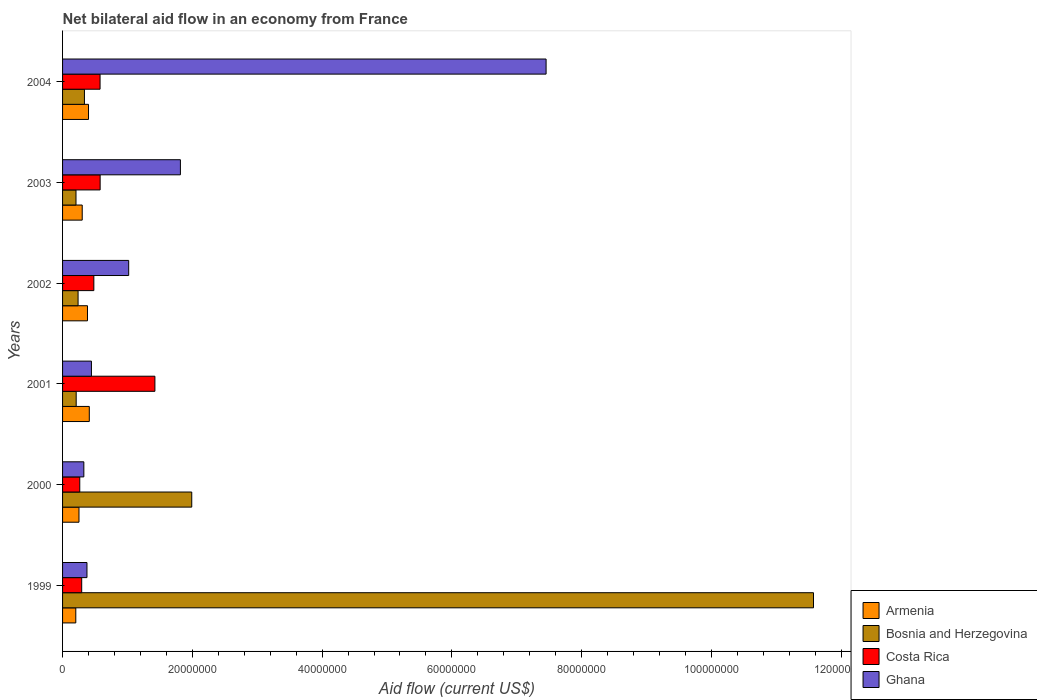How many different coloured bars are there?
Make the answer very short. 4. How many groups of bars are there?
Ensure brevity in your answer.  6. Are the number of bars per tick equal to the number of legend labels?
Make the answer very short. Yes. Are the number of bars on each tick of the Y-axis equal?
Give a very brief answer. Yes. In how many cases, is the number of bars for a given year not equal to the number of legend labels?
Keep it short and to the point. 0. What is the net bilateral aid flow in Armenia in 2003?
Your answer should be very brief. 3.03e+06. Across all years, what is the maximum net bilateral aid flow in Armenia?
Your answer should be very brief. 4.12e+06. Across all years, what is the minimum net bilateral aid flow in Bosnia and Herzegovina?
Your answer should be very brief. 2.07e+06. What is the total net bilateral aid flow in Costa Rica in the graph?
Provide a succinct answer. 3.62e+07. What is the difference between the net bilateral aid flow in Costa Rica in 2001 and that in 2003?
Offer a terse response. 8.44e+06. What is the difference between the net bilateral aid flow in Costa Rica in 2001 and the net bilateral aid flow in Armenia in 2003?
Offer a terse response. 1.12e+07. What is the average net bilateral aid flow in Armenia per year?
Your answer should be compact. 3.26e+06. In the year 2000, what is the difference between the net bilateral aid flow in Ghana and net bilateral aid flow in Costa Rica?
Make the answer very short. 6.30e+05. What is the ratio of the net bilateral aid flow in Bosnia and Herzegovina in 2001 to that in 2003?
Offer a terse response. 1.01. Is the net bilateral aid flow in Bosnia and Herzegovina in 2002 less than that in 2004?
Keep it short and to the point. Yes. What is the difference between the highest and the second highest net bilateral aid flow in Armenia?
Keep it short and to the point. 1.20e+05. What is the difference between the highest and the lowest net bilateral aid flow in Ghana?
Your response must be concise. 7.12e+07. In how many years, is the net bilateral aid flow in Costa Rica greater than the average net bilateral aid flow in Costa Rica taken over all years?
Offer a very short reply. 1. Is the sum of the net bilateral aid flow in Ghana in 2000 and 2004 greater than the maximum net bilateral aid flow in Armenia across all years?
Offer a terse response. Yes. Is it the case that in every year, the sum of the net bilateral aid flow in Costa Rica and net bilateral aid flow in Ghana is greater than the sum of net bilateral aid flow in Armenia and net bilateral aid flow in Bosnia and Herzegovina?
Give a very brief answer. No. What does the 4th bar from the top in 2002 represents?
Offer a terse response. Armenia. What does the 1st bar from the bottom in 2004 represents?
Make the answer very short. Armenia. Is it the case that in every year, the sum of the net bilateral aid flow in Costa Rica and net bilateral aid flow in Armenia is greater than the net bilateral aid flow in Bosnia and Herzegovina?
Offer a terse response. No. How many years are there in the graph?
Provide a short and direct response. 6. What is the difference between two consecutive major ticks on the X-axis?
Offer a very short reply. 2.00e+07. Are the values on the major ticks of X-axis written in scientific E-notation?
Offer a very short reply. No. Does the graph contain grids?
Offer a very short reply. No. Where does the legend appear in the graph?
Provide a succinct answer. Bottom right. How many legend labels are there?
Give a very brief answer. 4. What is the title of the graph?
Your answer should be very brief. Net bilateral aid flow in an economy from France. Does "Uganda" appear as one of the legend labels in the graph?
Provide a succinct answer. No. What is the label or title of the Y-axis?
Provide a short and direct response. Years. What is the Aid flow (current US$) of Armenia in 1999?
Make the answer very short. 2.04e+06. What is the Aid flow (current US$) in Bosnia and Herzegovina in 1999?
Give a very brief answer. 1.16e+08. What is the Aid flow (current US$) of Costa Rica in 1999?
Provide a succinct answer. 2.95e+06. What is the Aid flow (current US$) in Ghana in 1999?
Offer a terse response. 3.76e+06. What is the Aid flow (current US$) of Armenia in 2000?
Keep it short and to the point. 2.53e+06. What is the Aid flow (current US$) in Bosnia and Herzegovina in 2000?
Offer a very short reply. 1.99e+07. What is the Aid flow (current US$) in Costa Rica in 2000?
Provide a short and direct response. 2.65e+06. What is the Aid flow (current US$) of Ghana in 2000?
Your response must be concise. 3.28e+06. What is the Aid flow (current US$) of Armenia in 2001?
Make the answer very short. 4.12e+06. What is the Aid flow (current US$) in Bosnia and Herzegovina in 2001?
Your response must be concise. 2.10e+06. What is the Aid flow (current US$) of Costa Rica in 2001?
Ensure brevity in your answer.  1.42e+07. What is the Aid flow (current US$) in Ghana in 2001?
Ensure brevity in your answer.  4.45e+06. What is the Aid flow (current US$) in Armenia in 2002?
Offer a terse response. 3.84e+06. What is the Aid flow (current US$) of Bosnia and Herzegovina in 2002?
Give a very brief answer. 2.39e+06. What is the Aid flow (current US$) of Costa Rica in 2002?
Your answer should be compact. 4.82e+06. What is the Aid flow (current US$) in Ghana in 2002?
Your response must be concise. 1.02e+07. What is the Aid flow (current US$) in Armenia in 2003?
Your answer should be very brief. 3.03e+06. What is the Aid flow (current US$) of Bosnia and Herzegovina in 2003?
Your answer should be compact. 2.07e+06. What is the Aid flow (current US$) of Costa Rica in 2003?
Keep it short and to the point. 5.79e+06. What is the Aid flow (current US$) of Ghana in 2003?
Provide a short and direct response. 1.82e+07. What is the Aid flow (current US$) of Armenia in 2004?
Ensure brevity in your answer.  4.00e+06. What is the Aid flow (current US$) of Bosnia and Herzegovina in 2004?
Ensure brevity in your answer.  3.37e+06. What is the Aid flow (current US$) in Costa Rica in 2004?
Your response must be concise. 5.78e+06. What is the Aid flow (current US$) of Ghana in 2004?
Provide a succinct answer. 7.45e+07. Across all years, what is the maximum Aid flow (current US$) in Armenia?
Offer a terse response. 4.12e+06. Across all years, what is the maximum Aid flow (current US$) of Bosnia and Herzegovina?
Your response must be concise. 1.16e+08. Across all years, what is the maximum Aid flow (current US$) in Costa Rica?
Keep it short and to the point. 1.42e+07. Across all years, what is the maximum Aid flow (current US$) in Ghana?
Offer a terse response. 7.45e+07. Across all years, what is the minimum Aid flow (current US$) of Armenia?
Offer a very short reply. 2.04e+06. Across all years, what is the minimum Aid flow (current US$) of Bosnia and Herzegovina?
Provide a succinct answer. 2.07e+06. Across all years, what is the minimum Aid flow (current US$) in Costa Rica?
Ensure brevity in your answer.  2.65e+06. Across all years, what is the minimum Aid flow (current US$) in Ghana?
Offer a very short reply. 3.28e+06. What is the total Aid flow (current US$) of Armenia in the graph?
Your answer should be compact. 1.96e+07. What is the total Aid flow (current US$) in Bosnia and Herzegovina in the graph?
Offer a terse response. 1.46e+08. What is the total Aid flow (current US$) in Costa Rica in the graph?
Your response must be concise. 3.62e+07. What is the total Aid flow (current US$) of Ghana in the graph?
Your answer should be compact. 1.14e+08. What is the difference between the Aid flow (current US$) of Armenia in 1999 and that in 2000?
Provide a short and direct response. -4.90e+05. What is the difference between the Aid flow (current US$) in Bosnia and Herzegovina in 1999 and that in 2000?
Keep it short and to the point. 9.58e+07. What is the difference between the Aid flow (current US$) in Costa Rica in 1999 and that in 2000?
Your response must be concise. 3.00e+05. What is the difference between the Aid flow (current US$) of Ghana in 1999 and that in 2000?
Your answer should be compact. 4.80e+05. What is the difference between the Aid flow (current US$) in Armenia in 1999 and that in 2001?
Provide a short and direct response. -2.08e+06. What is the difference between the Aid flow (current US$) in Bosnia and Herzegovina in 1999 and that in 2001?
Make the answer very short. 1.14e+08. What is the difference between the Aid flow (current US$) in Costa Rica in 1999 and that in 2001?
Your response must be concise. -1.13e+07. What is the difference between the Aid flow (current US$) in Ghana in 1999 and that in 2001?
Provide a short and direct response. -6.90e+05. What is the difference between the Aid flow (current US$) of Armenia in 1999 and that in 2002?
Provide a succinct answer. -1.80e+06. What is the difference between the Aid flow (current US$) of Bosnia and Herzegovina in 1999 and that in 2002?
Your answer should be very brief. 1.13e+08. What is the difference between the Aid flow (current US$) of Costa Rica in 1999 and that in 2002?
Offer a terse response. -1.87e+06. What is the difference between the Aid flow (current US$) in Ghana in 1999 and that in 2002?
Ensure brevity in your answer.  -6.43e+06. What is the difference between the Aid flow (current US$) in Armenia in 1999 and that in 2003?
Ensure brevity in your answer.  -9.90e+05. What is the difference between the Aid flow (current US$) of Bosnia and Herzegovina in 1999 and that in 2003?
Make the answer very short. 1.14e+08. What is the difference between the Aid flow (current US$) of Costa Rica in 1999 and that in 2003?
Offer a very short reply. -2.84e+06. What is the difference between the Aid flow (current US$) of Ghana in 1999 and that in 2003?
Ensure brevity in your answer.  -1.44e+07. What is the difference between the Aid flow (current US$) of Armenia in 1999 and that in 2004?
Make the answer very short. -1.96e+06. What is the difference between the Aid flow (current US$) of Bosnia and Herzegovina in 1999 and that in 2004?
Your answer should be very brief. 1.12e+08. What is the difference between the Aid flow (current US$) of Costa Rica in 1999 and that in 2004?
Give a very brief answer. -2.83e+06. What is the difference between the Aid flow (current US$) in Ghana in 1999 and that in 2004?
Keep it short and to the point. -7.08e+07. What is the difference between the Aid flow (current US$) of Armenia in 2000 and that in 2001?
Offer a very short reply. -1.59e+06. What is the difference between the Aid flow (current US$) in Bosnia and Herzegovina in 2000 and that in 2001?
Make the answer very short. 1.78e+07. What is the difference between the Aid flow (current US$) in Costa Rica in 2000 and that in 2001?
Your answer should be very brief. -1.16e+07. What is the difference between the Aid flow (current US$) in Ghana in 2000 and that in 2001?
Your answer should be compact. -1.17e+06. What is the difference between the Aid flow (current US$) of Armenia in 2000 and that in 2002?
Keep it short and to the point. -1.31e+06. What is the difference between the Aid flow (current US$) in Bosnia and Herzegovina in 2000 and that in 2002?
Give a very brief answer. 1.75e+07. What is the difference between the Aid flow (current US$) of Costa Rica in 2000 and that in 2002?
Keep it short and to the point. -2.17e+06. What is the difference between the Aid flow (current US$) of Ghana in 2000 and that in 2002?
Provide a succinct answer. -6.91e+06. What is the difference between the Aid flow (current US$) in Armenia in 2000 and that in 2003?
Offer a terse response. -5.00e+05. What is the difference between the Aid flow (current US$) in Bosnia and Herzegovina in 2000 and that in 2003?
Give a very brief answer. 1.78e+07. What is the difference between the Aid flow (current US$) of Costa Rica in 2000 and that in 2003?
Keep it short and to the point. -3.14e+06. What is the difference between the Aid flow (current US$) of Ghana in 2000 and that in 2003?
Keep it short and to the point. -1.49e+07. What is the difference between the Aid flow (current US$) in Armenia in 2000 and that in 2004?
Your response must be concise. -1.47e+06. What is the difference between the Aid flow (current US$) in Bosnia and Herzegovina in 2000 and that in 2004?
Provide a short and direct response. 1.65e+07. What is the difference between the Aid flow (current US$) in Costa Rica in 2000 and that in 2004?
Give a very brief answer. -3.13e+06. What is the difference between the Aid flow (current US$) in Ghana in 2000 and that in 2004?
Make the answer very short. -7.12e+07. What is the difference between the Aid flow (current US$) in Costa Rica in 2001 and that in 2002?
Provide a succinct answer. 9.41e+06. What is the difference between the Aid flow (current US$) of Ghana in 2001 and that in 2002?
Offer a very short reply. -5.74e+06. What is the difference between the Aid flow (current US$) in Armenia in 2001 and that in 2003?
Your answer should be compact. 1.09e+06. What is the difference between the Aid flow (current US$) of Costa Rica in 2001 and that in 2003?
Provide a short and direct response. 8.44e+06. What is the difference between the Aid flow (current US$) in Ghana in 2001 and that in 2003?
Keep it short and to the point. -1.37e+07. What is the difference between the Aid flow (current US$) in Armenia in 2001 and that in 2004?
Your answer should be compact. 1.20e+05. What is the difference between the Aid flow (current US$) of Bosnia and Herzegovina in 2001 and that in 2004?
Your answer should be very brief. -1.27e+06. What is the difference between the Aid flow (current US$) in Costa Rica in 2001 and that in 2004?
Offer a terse response. 8.45e+06. What is the difference between the Aid flow (current US$) of Ghana in 2001 and that in 2004?
Provide a short and direct response. -7.01e+07. What is the difference between the Aid flow (current US$) in Armenia in 2002 and that in 2003?
Give a very brief answer. 8.10e+05. What is the difference between the Aid flow (current US$) in Bosnia and Herzegovina in 2002 and that in 2003?
Provide a succinct answer. 3.20e+05. What is the difference between the Aid flow (current US$) of Costa Rica in 2002 and that in 2003?
Give a very brief answer. -9.70e+05. What is the difference between the Aid flow (current US$) of Ghana in 2002 and that in 2003?
Your answer should be compact. -7.97e+06. What is the difference between the Aid flow (current US$) of Armenia in 2002 and that in 2004?
Keep it short and to the point. -1.60e+05. What is the difference between the Aid flow (current US$) of Bosnia and Herzegovina in 2002 and that in 2004?
Ensure brevity in your answer.  -9.80e+05. What is the difference between the Aid flow (current US$) in Costa Rica in 2002 and that in 2004?
Make the answer very short. -9.60e+05. What is the difference between the Aid flow (current US$) of Ghana in 2002 and that in 2004?
Make the answer very short. -6.43e+07. What is the difference between the Aid flow (current US$) of Armenia in 2003 and that in 2004?
Give a very brief answer. -9.70e+05. What is the difference between the Aid flow (current US$) in Bosnia and Herzegovina in 2003 and that in 2004?
Offer a very short reply. -1.30e+06. What is the difference between the Aid flow (current US$) in Costa Rica in 2003 and that in 2004?
Provide a short and direct response. 10000. What is the difference between the Aid flow (current US$) of Ghana in 2003 and that in 2004?
Offer a terse response. -5.64e+07. What is the difference between the Aid flow (current US$) in Armenia in 1999 and the Aid flow (current US$) in Bosnia and Herzegovina in 2000?
Keep it short and to the point. -1.79e+07. What is the difference between the Aid flow (current US$) of Armenia in 1999 and the Aid flow (current US$) of Costa Rica in 2000?
Give a very brief answer. -6.10e+05. What is the difference between the Aid flow (current US$) in Armenia in 1999 and the Aid flow (current US$) in Ghana in 2000?
Offer a very short reply. -1.24e+06. What is the difference between the Aid flow (current US$) of Bosnia and Herzegovina in 1999 and the Aid flow (current US$) of Costa Rica in 2000?
Offer a terse response. 1.13e+08. What is the difference between the Aid flow (current US$) of Bosnia and Herzegovina in 1999 and the Aid flow (current US$) of Ghana in 2000?
Provide a short and direct response. 1.12e+08. What is the difference between the Aid flow (current US$) in Costa Rica in 1999 and the Aid flow (current US$) in Ghana in 2000?
Provide a succinct answer. -3.30e+05. What is the difference between the Aid flow (current US$) in Armenia in 1999 and the Aid flow (current US$) in Bosnia and Herzegovina in 2001?
Your answer should be compact. -6.00e+04. What is the difference between the Aid flow (current US$) of Armenia in 1999 and the Aid flow (current US$) of Costa Rica in 2001?
Your response must be concise. -1.22e+07. What is the difference between the Aid flow (current US$) in Armenia in 1999 and the Aid flow (current US$) in Ghana in 2001?
Your response must be concise. -2.41e+06. What is the difference between the Aid flow (current US$) of Bosnia and Herzegovina in 1999 and the Aid flow (current US$) of Costa Rica in 2001?
Offer a very short reply. 1.02e+08. What is the difference between the Aid flow (current US$) in Bosnia and Herzegovina in 1999 and the Aid flow (current US$) in Ghana in 2001?
Provide a succinct answer. 1.11e+08. What is the difference between the Aid flow (current US$) of Costa Rica in 1999 and the Aid flow (current US$) of Ghana in 2001?
Make the answer very short. -1.50e+06. What is the difference between the Aid flow (current US$) in Armenia in 1999 and the Aid flow (current US$) in Bosnia and Herzegovina in 2002?
Give a very brief answer. -3.50e+05. What is the difference between the Aid flow (current US$) of Armenia in 1999 and the Aid flow (current US$) of Costa Rica in 2002?
Your answer should be very brief. -2.78e+06. What is the difference between the Aid flow (current US$) of Armenia in 1999 and the Aid flow (current US$) of Ghana in 2002?
Give a very brief answer. -8.15e+06. What is the difference between the Aid flow (current US$) in Bosnia and Herzegovina in 1999 and the Aid flow (current US$) in Costa Rica in 2002?
Your answer should be compact. 1.11e+08. What is the difference between the Aid flow (current US$) in Bosnia and Herzegovina in 1999 and the Aid flow (current US$) in Ghana in 2002?
Ensure brevity in your answer.  1.06e+08. What is the difference between the Aid flow (current US$) in Costa Rica in 1999 and the Aid flow (current US$) in Ghana in 2002?
Ensure brevity in your answer.  -7.24e+06. What is the difference between the Aid flow (current US$) of Armenia in 1999 and the Aid flow (current US$) of Bosnia and Herzegovina in 2003?
Provide a short and direct response. -3.00e+04. What is the difference between the Aid flow (current US$) of Armenia in 1999 and the Aid flow (current US$) of Costa Rica in 2003?
Keep it short and to the point. -3.75e+06. What is the difference between the Aid flow (current US$) in Armenia in 1999 and the Aid flow (current US$) in Ghana in 2003?
Your answer should be compact. -1.61e+07. What is the difference between the Aid flow (current US$) in Bosnia and Herzegovina in 1999 and the Aid flow (current US$) in Costa Rica in 2003?
Your answer should be very brief. 1.10e+08. What is the difference between the Aid flow (current US$) of Bosnia and Herzegovina in 1999 and the Aid flow (current US$) of Ghana in 2003?
Offer a very short reply. 9.76e+07. What is the difference between the Aid flow (current US$) of Costa Rica in 1999 and the Aid flow (current US$) of Ghana in 2003?
Your answer should be compact. -1.52e+07. What is the difference between the Aid flow (current US$) of Armenia in 1999 and the Aid flow (current US$) of Bosnia and Herzegovina in 2004?
Provide a succinct answer. -1.33e+06. What is the difference between the Aid flow (current US$) in Armenia in 1999 and the Aid flow (current US$) in Costa Rica in 2004?
Your answer should be very brief. -3.74e+06. What is the difference between the Aid flow (current US$) in Armenia in 1999 and the Aid flow (current US$) in Ghana in 2004?
Ensure brevity in your answer.  -7.25e+07. What is the difference between the Aid flow (current US$) in Bosnia and Herzegovina in 1999 and the Aid flow (current US$) in Costa Rica in 2004?
Make the answer very short. 1.10e+08. What is the difference between the Aid flow (current US$) in Bosnia and Herzegovina in 1999 and the Aid flow (current US$) in Ghana in 2004?
Keep it short and to the point. 4.12e+07. What is the difference between the Aid flow (current US$) of Costa Rica in 1999 and the Aid flow (current US$) of Ghana in 2004?
Make the answer very short. -7.16e+07. What is the difference between the Aid flow (current US$) in Armenia in 2000 and the Aid flow (current US$) in Costa Rica in 2001?
Provide a short and direct response. -1.17e+07. What is the difference between the Aid flow (current US$) of Armenia in 2000 and the Aid flow (current US$) of Ghana in 2001?
Provide a short and direct response. -1.92e+06. What is the difference between the Aid flow (current US$) in Bosnia and Herzegovina in 2000 and the Aid flow (current US$) in Costa Rica in 2001?
Make the answer very short. 5.68e+06. What is the difference between the Aid flow (current US$) in Bosnia and Herzegovina in 2000 and the Aid flow (current US$) in Ghana in 2001?
Ensure brevity in your answer.  1.55e+07. What is the difference between the Aid flow (current US$) in Costa Rica in 2000 and the Aid flow (current US$) in Ghana in 2001?
Make the answer very short. -1.80e+06. What is the difference between the Aid flow (current US$) of Armenia in 2000 and the Aid flow (current US$) of Bosnia and Herzegovina in 2002?
Provide a succinct answer. 1.40e+05. What is the difference between the Aid flow (current US$) in Armenia in 2000 and the Aid flow (current US$) in Costa Rica in 2002?
Give a very brief answer. -2.29e+06. What is the difference between the Aid flow (current US$) in Armenia in 2000 and the Aid flow (current US$) in Ghana in 2002?
Your response must be concise. -7.66e+06. What is the difference between the Aid flow (current US$) of Bosnia and Herzegovina in 2000 and the Aid flow (current US$) of Costa Rica in 2002?
Your response must be concise. 1.51e+07. What is the difference between the Aid flow (current US$) in Bosnia and Herzegovina in 2000 and the Aid flow (current US$) in Ghana in 2002?
Provide a short and direct response. 9.72e+06. What is the difference between the Aid flow (current US$) in Costa Rica in 2000 and the Aid flow (current US$) in Ghana in 2002?
Make the answer very short. -7.54e+06. What is the difference between the Aid flow (current US$) in Armenia in 2000 and the Aid flow (current US$) in Costa Rica in 2003?
Ensure brevity in your answer.  -3.26e+06. What is the difference between the Aid flow (current US$) in Armenia in 2000 and the Aid flow (current US$) in Ghana in 2003?
Your answer should be compact. -1.56e+07. What is the difference between the Aid flow (current US$) of Bosnia and Herzegovina in 2000 and the Aid flow (current US$) of Costa Rica in 2003?
Your answer should be very brief. 1.41e+07. What is the difference between the Aid flow (current US$) in Bosnia and Herzegovina in 2000 and the Aid flow (current US$) in Ghana in 2003?
Make the answer very short. 1.75e+06. What is the difference between the Aid flow (current US$) of Costa Rica in 2000 and the Aid flow (current US$) of Ghana in 2003?
Give a very brief answer. -1.55e+07. What is the difference between the Aid flow (current US$) of Armenia in 2000 and the Aid flow (current US$) of Bosnia and Herzegovina in 2004?
Provide a short and direct response. -8.40e+05. What is the difference between the Aid flow (current US$) of Armenia in 2000 and the Aid flow (current US$) of Costa Rica in 2004?
Give a very brief answer. -3.25e+06. What is the difference between the Aid flow (current US$) of Armenia in 2000 and the Aid flow (current US$) of Ghana in 2004?
Your response must be concise. -7.20e+07. What is the difference between the Aid flow (current US$) of Bosnia and Herzegovina in 2000 and the Aid flow (current US$) of Costa Rica in 2004?
Your response must be concise. 1.41e+07. What is the difference between the Aid flow (current US$) of Bosnia and Herzegovina in 2000 and the Aid flow (current US$) of Ghana in 2004?
Ensure brevity in your answer.  -5.46e+07. What is the difference between the Aid flow (current US$) in Costa Rica in 2000 and the Aid flow (current US$) in Ghana in 2004?
Provide a short and direct response. -7.19e+07. What is the difference between the Aid flow (current US$) of Armenia in 2001 and the Aid flow (current US$) of Bosnia and Herzegovina in 2002?
Your answer should be compact. 1.73e+06. What is the difference between the Aid flow (current US$) in Armenia in 2001 and the Aid flow (current US$) in Costa Rica in 2002?
Give a very brief answer. -7.00e+05. What is the difference between the Aid flow (current US$) in Armenia in 2001 and the Aid flow (current US$) in Ghana in 2002?
Your response must be concise. -6.07e+06. What is the difference between the Aid flow (current US$) in Bosnia and Herzegovina in 2001 and the Aid flow (current US$) in Costa Rica in 2002?
Your answer should be compact. -2.72e+06. What is the difference between the Aid flow (current US$) of Bosnia and Herzegovina in 2001 and the Aid flow (current US$) of Ghana in 2002?
Ensure brevity in your answer.  -8.09e+06. What is the difference between the Aid flow (current US$) in Costa Rica in 2001 and the Aid flow (current US$) in Ghana in 2002?
Offer a terse response. 4.04e+06. What is the difference between the Aid flow (current US$) in Armenia in 2001 and the Aid flow (current US$) in Bosnia and Herzegovina in 2003?
Offer a terse response. 2.05e+06. What is the difference between the Aid flow (current US$) of Armenia in 2001 and the Aid flow (current US$) of Costa Rica in 2003?
Ensure brevity in your answer.  -1.67e+06. What is the difference between the Aid flow (current US$) of Armenia in 2001 and the Aid flow (current US$) of Ghana in 2003?
Provide a short and direct response. -1.40e+07. What is the difference between the Aid flow (current US$) of Bosnia and Herzegovina in 2001 and the Aid flow (current US$) of Costa Rica in 2003?
Make the answer very short. -3.69e+06. What is the difference between the Aid flow (current US$) in Bosnia and Herzegovina in 2001 and the Aid flow (current US$) in Ghana in 2003?
Ensure brevity in your answer.  -1.61e+07. What is the difference between the Aid flow (current US$) of Costa Rica in 2001 and the Aid flow (current US$) of Ghana in 2003?
Offer a terse response. -3.93e+06. What is the difference between the Aid flow (current US$) of Armenia in 2001 and the Aid flow (current US$) of Bosnia and Herzegovina in 2004?
Make the answer very short. 7.50e+05. What is the difference between the Aid flow (current US$) of Armenia in 2001 and the Aid flow (current US$) of Costa Rica in 2004?
Your answer should be compact. -1.66e+06. What is the difference between the Aid flow (current US$) in Armenia in 2001 and the Aid flow (current US$) in Ghana in 2004?
Your answer should be very brief. -7.04e+07. What is the difference between the Aid flow (current US$) in Bosnia and Herzegovina in 2001 and the Aid flow (current US$) in Costa Rica in 2004?
Provide a succinct answer. -3.68e+06. What is the difference between the Aid flow (current US$) of Bosnia and Herzegovina in 2001 and the Aid flow (current US$) of Ghana in 2004?
Provide a short and direct response. -7.24e+07. What is the difference between the Aid flow (current US$) of Costa Rica in 2001 and the Aid flow (current US$) of Ghana in 2004?
Your answer should be compact. -6.03e+07. What is the difference between the Aid flow (current US$) in Armenia in 2002 and the Aid flow (current US$) in Bosnia and Herzegovina in 2003?
Your response must be concise. 1.77e+06. What is the difference between the Aid flow (current US$) of Armenia in 2002 and the Aid flow (current US$) of Costa Rica in 2003?
Your response must be concise. -1.95e+06. What is the difference between the Aid flow (current US$) of Armenia in 2002 and the Aid flow (current US$) of Ghana in 2003?
Make the answer very short. -1.43e+07. What is the difference between the Aid flow (current US$) of Bosnia and Herzegovina in 2002 and the Aid flow (current US$) of Costa Rica in 2003?
Offer a terse response. -3.40e+06. What is the difference between the Aid flow (current US$) in Bosnia and Herzegovina in 2002 and the Aid flow (current US$) in Ghana in 2003?
Keep it short and to the point. -1.58e+07. What is the difference between the Aid flow (current US$) of Costa Rica in 2002 and the Aid flow (current US$) of Ghana in 2003?
Ensure brevity in your answer.  -1.33e+07. What is the difference between the Aid flow (current US$) in Armenia in 2002 and the Aid flow (current US$) in Costa Rica in 2004?
Give a very brief answer. -1.94e+06. What is the difference between the Aid flow (current US$) in Armenia in 2002 and the Aid flow (current US$) in Ghana in 2004?
Offer a very short reply. -7.07e+07. What is the difference between the Aid flow (current US$) in Bosnia and Herzegovina in 2002 and the Aid flow (current US$) in Costa Rica in 2004?
Give a very brief answer. -3.39e+06. What is the difference between the Aid flow (current US$) of Bosnia and Herzegovina in 2002 and the Aid flow (current US$) of Ghana in 2004?
Ensure brevity in your answer.  -7.21e+07. What is the difference between the Aid flow (current US$) of Costa Rica in 2002 and the Aid flow (current US$) of Ghana in 2004?
Your answer should be very brief. -6.97e+07. What is the difference between the Aid flow (current US$) of Armenia in 2003 and the Aid flow (current US$) of Costa Rica in 2004?
Offer a very short reply. -2.75e+06. What is the difference between the Aid flow (current US$) of Armenia in 2003 and the Aid flow (current US$) of Ghana in 2004?
Offer a terse response. -7.15e+07. What is the difference between the Aid flow (current US$) of Bosnia and Herzegovina in 2003 and the Aid flow (current US$) of Costa Rica in 2004?
Provide a short and direct response. -3.71e+06. What is the difference between the Aid flow (current US$) in Bosnia and Herzegovina in 2003 and the Aid flow (current US$) in Ghana in 2004?
Ensure brevity in your answer.  -7.24e+07. What is the difference between the Aid flow (current US$) of Costa Rica in 2003 and the Aid flow (current US$) of Ghana in 2004?
Give a very brief answer. -6.87e+07. What is the average Aid flow (current US$) in Armenia per year?
Your response must be concise. 3.26e+06. What is the average Aid flow (current US$) of Bosnia and Herzegovina per year?
Your answer should be compact. 2.43e+07. What is the average Aid flow (current US$) of Costa Rica per year?
Keep it short and to the point. 6.04e+06. What is the average Aid flow (current US$) of Ghana per year?
Your answer should be very brief. 1.91e+07. In the year 1999, what is the difference between the Aid flow (current US$) in Armenia and Aid flow (current US$) in Bosnia and Herzegovina?
Your answer should be compact. -1.14e+08. In the year 1999, what is the difference between the Aid flow (current US$) of Armenia and Aid flow (current US$) of Costa Rica?
Keep it short and to the point. -9.10e+05. In the year 1999, what is the difference between the Aid flow (current US$) in Armenia and Aid flow (current US$) in Ghana?
Offer a terse response. -1.72e+06. In the year 1999, what is the difference between the Aid flow (current US$) in Bosnia and Herzegovina and Aid flow (current US$) in Costa Rica?
Your response must be concise. 1.13e+08. In the year 1999, what is the difference between the Aid flow (current US$) in Bosnia and Herzegovina and Aid flow (current US$) in Ghana?
Your answer should be very brief. 1.12e+08. In the year 1999, what is the difference between the Aid flow (current US$) in Costa Rica and Aid flow (current US$) in Ghana?
Give a very brief answer. -8.10e+05. In the year 2000, what is the difference between the Aid flow (current US$) in Armenia and Aid flow (current US$) in Bosnia and Herzegovina?
Offer a terse response. -1.74e+07. In the year 2000, what is the difference between the Aid flow (current US$) of Armenia and Aid flow (current US$) of Costa Rica?
Your answer should be very brief. -1.20e+05. In the year 2000, what is the difference between the Aid flow (current US$) in Armenia and Aid flow (current US$) in Ghana?
Provide a short and direct response. -7.50e+05. In the year 2000, what is the difference between the Aid flow (current US$) in Bosnia and Herzegovina and Aid flow (current US$) in Costa Rica?
Give a very brief answer. 1.73e+07. In the year 2000, what is the difference between the Aid flow (current US$) of Bosnia and Herzegovina and Aid flow (current US$) of Ghana?
Your answer should be compact. 1.66e+07. In the year 2000, what is the difference between the Aid flow (current US$) of Costa Rica and Aid flow (current US$) of Ghana?
Provide a short and direct response. -6.30e+05. In the year 2001, what is the difference between the Aid flow (current US$) of Armenia and Aid flow (current US$) of Bosnia and Herzegovina?
Provide a succinct answer. 2.02e+06. In the year 2001, what is the difference between the Aid flow (current US$) of Armenia and Aid flow (current US$) of Costa Rica?
Keep it short and to the point. -1.01e+07. In the year 2001, what is the difference between the Aid flow (current US$) in Armenia and Aid flow (current US$) in Ghana?
Provide a succinct answer. -3.30e+05. In the year 2001, what is the difference between the Aid flow (current US$) of Bosnia and Herzegovina and Aid flow (current US$) of Costa Rica?
Provide a succinct answer. -1.21e+07. In the year 2001, what is the difference between the Aid flow (current US$) in Bosnia and Herzegovina and Aid flow (current US$) in Ghana?
Offer a very short reply. -2.35e+06. In the year 2001, what is the difference between the Aid flow (current US$) of Costa Rica and Aid flow (current US$) of Ghana?
Ensure brevity in your answer.  9.78e+06. In the year 2002, what is the difference between the Aid flow (current US$) of Armenia and Aid flow (current US$) of Bosnia and Herzegovina?
Your answer should be very brief. 1.45e+06. In the year 2002, what is the difference between the Aid flow (current US$) in Armenia and Aid flow (current US$) in Costa Rica?
Offer a terse response. -9.80e+05. In the year 2002, what is the difference between the Aid flow (current US$) of Armenia and Aid flow (current US$) of Ghana?
Keep it short and to the point. -6.35e+06. In the year 2002, what is the difference between the Aid flow (current US$) of Bosnia and Herzegovina and Aid flow (current US$) of Costa Rica?
Your answer should be very brief. -2.43e+06. In the year 2002, what is the difference between the Aid flow (current US$) of Bosnia and Herzegovina and Aid flow (current US$) of Ghana?
Your answer should be very brief. -7.80e+06. In the year 2002, what is the difference between the Aid flow (current US$) of Costa Rica and Aid flow (current US$) of Ghana?
Provide a short and direct response. -5.37e+06. In the year 2003, what is the difference between the Aid flow (current US$) in Armenia and Aid flow (current US$) in Bosnia and Herzegovina?
Ensure brevity in your answer.  9.60e+05. In the year 2003, what is the difference between the Aid flow (current US$) in Armenia and Aid flow (current US$) in Costa Rica?
Give a very brief answer. -2.76e+06. In the year 2003, what is the difference between the Aid flow (current US$) of Armenia and Aid flow (current US$) of Ghana?
Your response must be concise. -1.51e+07. In the year 2003, what is the difference between the Aid flow (current US$) of Bosnia and Herzegovina and Aid flow (current US$) of Costa Rica?
Keep it short and to the point. -3.72e+06. In the year 2003, what is the difference between the Aid flow (current US$) in Bosnia and Herzegovina and Aid flow (current US$) in Ghana?
Give a very brief answer. -1.61e+07. In the year 2003, what is the difference between the Aid flow (current US$) in Costa Rica and Aid flow (current US$) in Ghana?
Make the answer very short. -1.24e+07. In the year 2004, what is the difference between the Aid flow (current US$) of Armenia and Aid flow (current US$) of Bosnia and Herzegovina?
Offer a terse response. 6.30e+05. In the year 2004, what is the difference between the Aid flow (current US$) of Armenia and Aid flow (current US$) of Costa Rica?
Provide a short and direct response. -1.78e+06. In the year 2004, what is the difference between the Aid flow (current US$) in Armenia and Aid flow (current US$) in Ghana?
Offer a terse response. -7.05e+07. In the year 2004, what is the difference between the Aid flow (current US$) in Bosnia and Herzegovina and Aid flow (current US$) in Costa Rica?
Keep it short and to the point. -2.41e+06. In the year 2004, what is the difference between the Aid flow (current US$) in Bosnia and Herzegovina and Aid flow (current US$) in Ghana?
Your answer should be very brief. -7.12e+07. In the year 2004, what is the difference between the Aid flow (current US$) in Costa Rica and Aid flow (current US$) in Ghana?
Offer a very short reply. -6.87e+07. What is the ratio of the Aid flow (current US$) in Armenia in 1999 to that in 2000?
Offer a terse response. 0.81. What is the ratio of the Aid flow (current US$) of Bosnia and Herzegovina in 1999 to that in 2000?
Ensure brevity in your answer.  5.81. What is the ratio of the Aid flow (current US$) in Costa Rica in 1999 to that in 2000?
Provide a short and direct response. 1.11. What is the ratio of the Aid flow (current US$) in Ghana in 1999 to that in 2000?
Provide a succinct answer. 1.15. What is the ratio of the Aid flow (current US$) in Armenia in 1999 to that in 2001?
Make the answer very short. 0.5. What is the ratio of the Aid flow (current US$) in Bosnia and Herzegovina in 1999 to that in 2001?
Provide a short and direct response. 55.11. What is the ratio of the Aid flow (current US$) in Costa Rica in 1999 to that in 2001?
Keep it short and to the point. 0.21. What is the ratio of the Aid flow (current US$) in Ghana in 1999 to that in 2001?
Give a very brief answer. 0.84. What is the ratio of the Aid flow (current US$) of Armenia in 1999 to that in 2002?
Keep it short and to the point. 0.53. What is the ratio of the Aid flow (current US$) in Bosnia and Herzegovina in 1999 to that in 2002?
Make the answer very short. 48.42. What is the ratio of the Aid flow (current US$) in Costa Rica in 1999 to that in 2002?
Make the answer very short. 0.61. What is the ratio of the Aid flow (current US$) of Ghana in 1999 to that in 2002?
Offer a very short reply. 0.37. What is the ratio of the Aid flow (current US$) of Armenia in 1999 to that in 2003?
Make the answer very short. 0.67. What is the ratio of the Aid flow (current US$) in Bosnia and Herzegovina in 1999 to that in 2003?
Keep it short and to the point. 55.91. What is the ratio of the Aid flow (current US$) in Costa Rica in 1999 to that in 2003?
Ensure brevity in your answer.  0.51. What is the ratio of the Aid flow (current US$) in Ghana in 1999 to that in 2003?
Make the answer very short. 0.21. What is the ratio of the Aid flow (current US$) of Armenia in 1999 to that in 2004?
Offer a terse response. 0.51. What is the ratio of the Aid flow (current US$) of Bosnia and Herzegovina in 1999 to that in 2004?
Give a very brief answer. 34.34. What is the ratio of the Aid flow (current US$) of Costa Rica in 1999 to that in 2004?
Provide a short and direct response. 0.51. What is the ratio of the Aid flow (current US$) in Ghana in 1999 to that in 2004?
Keep it short and to the point. 0.05. What is the ratio of the Aid flow (current US$) of Armenia in 2000 to that in 2001?
Make the answer very short. 0.61. What is the ratio of the Aid flow (current US$) in Bosnia and Herzegovina in 2000 to that in 2001?
Provide a short and direct response. 9.48. What is the ratio of the Aid flow (current US$) of Costa Rica in 2000 to that in 2001?
Provide a succinct answer. 0.19. What is the ratio of the Aid flow (current US$) of Ghana in 2000 to that in 2001?
Offer a very short reply. 0.74. What is the ratio of the Aid flow (current US$) of Armenia in 2000 to that in 2002?
Keep it short and to the point. 0.66. What is the ratio of the Aid flow (current US$) in Bosnia and Herzegovina in 2000 to that in 2002?
Your answer should be very brief. 8.33. What is the ratio of the Aid flow (current US$) in Costa Rica in 2000 to that in 2002?
Provide a succinct answer. 0.55. What is the ratio of the Aid flow (current US$) of Ghana in 2000 to that in 2002?
Provide a succinct answer. 0.32. What is the ratio of the Aid flow (current US$) of Armenia in 2000 to that in 2003?
Provide a short and direct response. 0.83. What is the ratio of the Aid flow (current US$) of Bosnia and Herzegovina in 2000 to that in 2003?
Keep it short and to the point. 9.62. What is the ratio of the Aid flow (current US$) in Costa Rica in 2000 to that in 2003?
Your answer should be very brief. 0.46. What is the ratio of the Aid flow (current US$) in Ghana in 2000 to that in 2003?
Make the answer very short. 0.18. What is the ratio of the Aid flow (current US$) in Armenia in 2000 to that in 2004?
Provide a succinct answer. 0.63. What is the ratio of the Aid flow (current US$) in Bosnia and Herzegovina in 2000 to that in 2004?
Ensure brevity in your answer.  5.91. What is the ratio of the Aid flow (current US$) in Costa Rica in 2000 to that in 2004?
Offer a terse response. 0.46. What is the ratio of the Aid flow (current US$) in Ghana in 2000 to that in 2004?
Make the answer very short. 0.04. What is the ratio of the Aid flow (current US$) of Armenia in 2001 to that in 2002?
Your answer should be compact. 1.07. What is the ratio of the Aid flow (current US$) of Bosnia and Herzegovina in 2001 to that in 2002?
Offer a terse response. 0.88. What is the ratio of the Aid flow (current US$) in Costa Rica in 2001 to that in 2002?
Offer a very short reply. 2.95. What is the ratio of the Aid flow (current US$) of Ghana in 2001 to that in 2002?
Offer a very short reply. 0.44. What is the ratio of the Aid flow (current US$) in Armenia in 2001 to that in 2003?
Keep it short and to the point. 1.36. What is the ratio of the Aid flow (current US$) in Bosnia and Herzegovina in 2001 to that in 2003?
Offer a terse response. 1.01. What is the ratio of the Aid flow (current US$) of Costa Rica in 2001 to that in 2003?
Offer a terse response. 2.46. What is the ratio of the Aid flow (current US$) of Ghana in 2001 to that in 2003?
Your response must be concise. 0.24. What is the ratio of the Aid flow (current US$) in Armenia in 2001 to that in 2004?
Make the answer very short. 1.03. What is the ratio of the Aid flow (current US$) of Bosnia and Herzegovina in 2001 to that in 2004?
Your answer should be compact. 0.62. What is the ratio of the Aid flow (current US$) of Costa Rica in 2001 to that in 2004?
Make the answer very short. 2.46. What is the ratio of the Aid flow (current US$) of Ghana in 2001 to that in 2004?
Your response must be concise. 0.06. What is the ratio of the Aid flow (current US$) of Armenia in 2002 to that in 2003?
Offer a terse response. 1.27. What is the ratio of the Aid flow (current US$) in Bosnia and Herzegovina in 2002 to that in 2003?
Give a very brief answer. 1.15. What is the ratio of the Aid flow (current US$) of Costa Rica in 2002 to that in 2003?
Offer a terse response. 0.83. What is the ratio of the Aid flow (current US$) of Ghana in 2002 to that in 2003?
Provide a short and direct response. 0.56. What is the ratio of the Aid flow (current US$) of Bosnia and Herzegovina in 2002 to that in 2004?
Make the answer very short. 0.71. What is the ratio of the Aid flow (current US$) of Costa Rica in 2002 to that in 2004?
Offer a terse response. 0.83. What is the ratio of the Aid flow (current US$) of Ghana in 2002 to that in 2004?
Keep it short and to the point. 0.14. What is the ratio of the Aid flow (current US$) in Armenia in 2003 to that in 2004?
Your response must be concise. 0.76. What is the ratio of the Aid flow (current US$) in Bosnia and Herzegovina in 2003 to that in 2004?
Ensure brevity in your answer.  0.61. What is the ratio of the Aid flow (current US$) of Costa Rica in 2003 to that in 2004?
Offer a very short reply. 1. What is the ratio of the Aid flow (current US$) in Ghana in 2003 to that in 2004?
Give a very brief answer. 0.24. What is the difference between the highest and the second highest Aid flow (current US$) of Armenia?
Ensure brevity in your answer.  1.20e+05. What is the difference between the highest and the second highest Aid flow (current US$) in Bosnia and Herzegovina?
Provide a succinct answer. 9.58e+07. What is the difference between the highest and the second highest Aid flow (current US$) in Costa Rica?
Offer a terse response. 8.44e+06. What is the difference between the highest and the second highest Aid flow (current US$) of Ghana?
Offer a very short reply. 5.64e+07. What is the difference between the highest and the lowest Aid flow (current US$) in Armenia?
Provide a short and direct response. 2.08e+06. What is the difference between the highest and the lowest Aid flow (current US$) in Bosnia and Herzegovina?
Provide a short and direct response. 1.14e+08. What is the difference between the highest and the lowest Aid flow (current US$) in Costa Rica?
Keep it short and to the point. 1.16e+07. What is the difference between the highest and the lowest Aid flow (current US$) in Ghana?
Keep it short and to the point. 7.12e+07. 